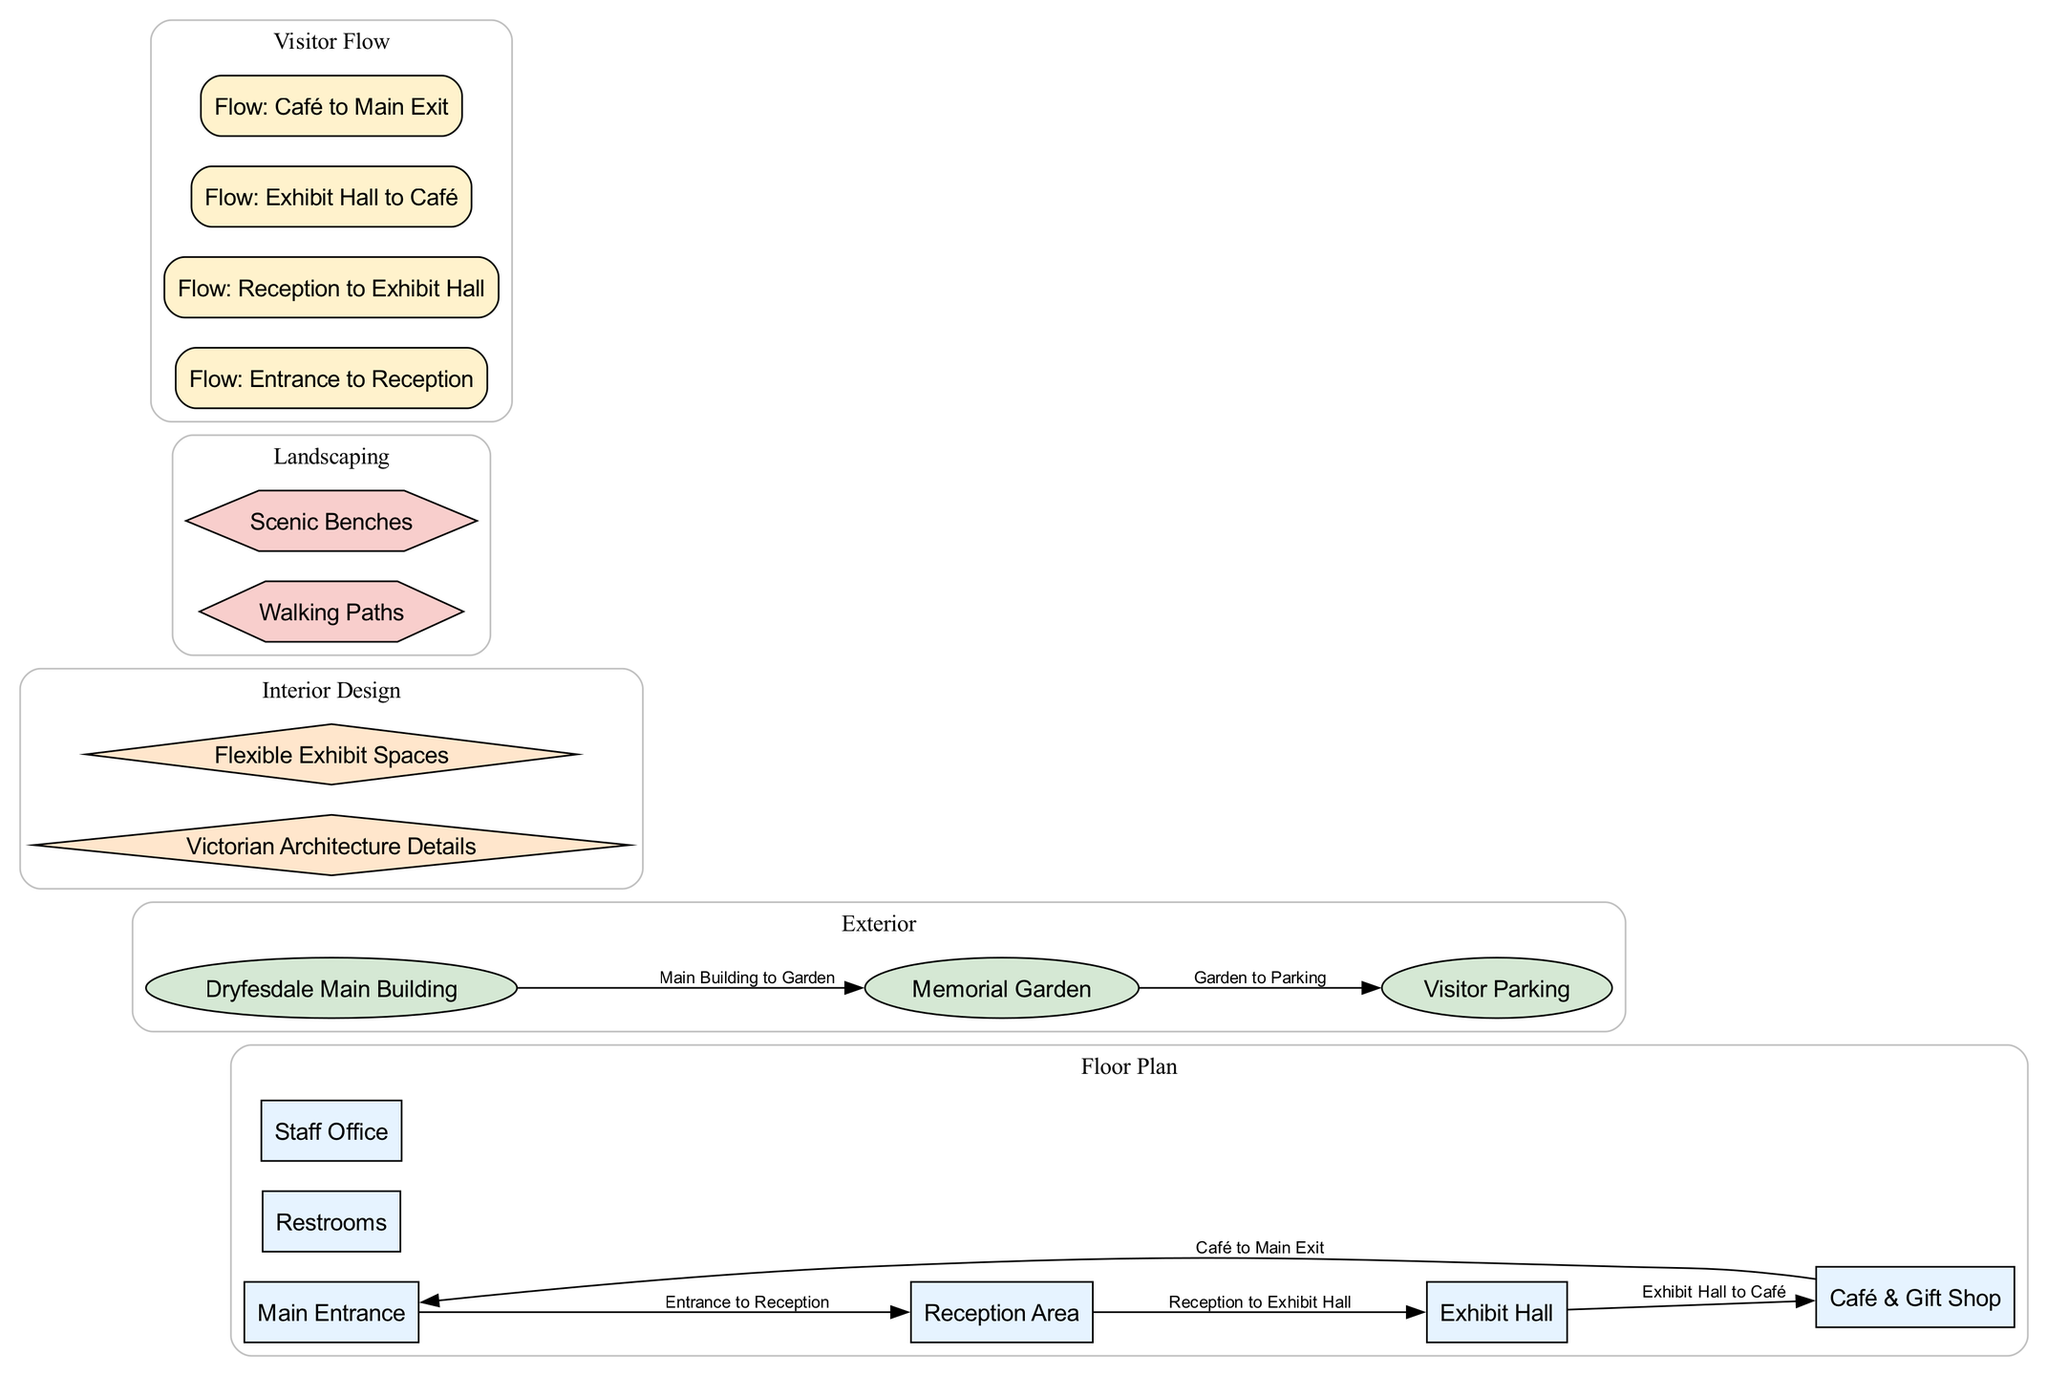What is the function of the "Café & Gift Shop" node? The "Café & Gift Shop" node represents a space in the centre where visitors can relax and purchase items. It is an essential part of the visitor experience within the building layout, serving refreshments and souvenirs.
Answer: Café & Gift Shop How many visitor flow connections are there in the diagram? By counting the edges that connect different nodes labeled as visitor flow, we see there are four connections: Entrance to Reception, Reception to Exhibit Hall, Exhibit Hall to Café, and Café to Main Exit.
Answer: 4 What is the transition from the "Exhibit Hall" to the "Café"? The transition labeled "Flow: Exhibit Hall to Café" indicates that visitors proceed directly from the exhibit area to the café, facilitating visitor flow in that direction.
Answer: Exhibit Hall to Café Which area connects to the "Memorial Garden"? The connection labeled "Main Building to Garden" shows that visitors can transition directly from the main building of Dryfesdale to the memorial garden, allowing for easy access to the outdoor area.
Answer: Main Building What is the shape of the "Reception Area"? The "Reception Area" node is classified as a "floor plan" type, which has a box shape according to the diagram’s node styles for visual representation.
Answer: Box 